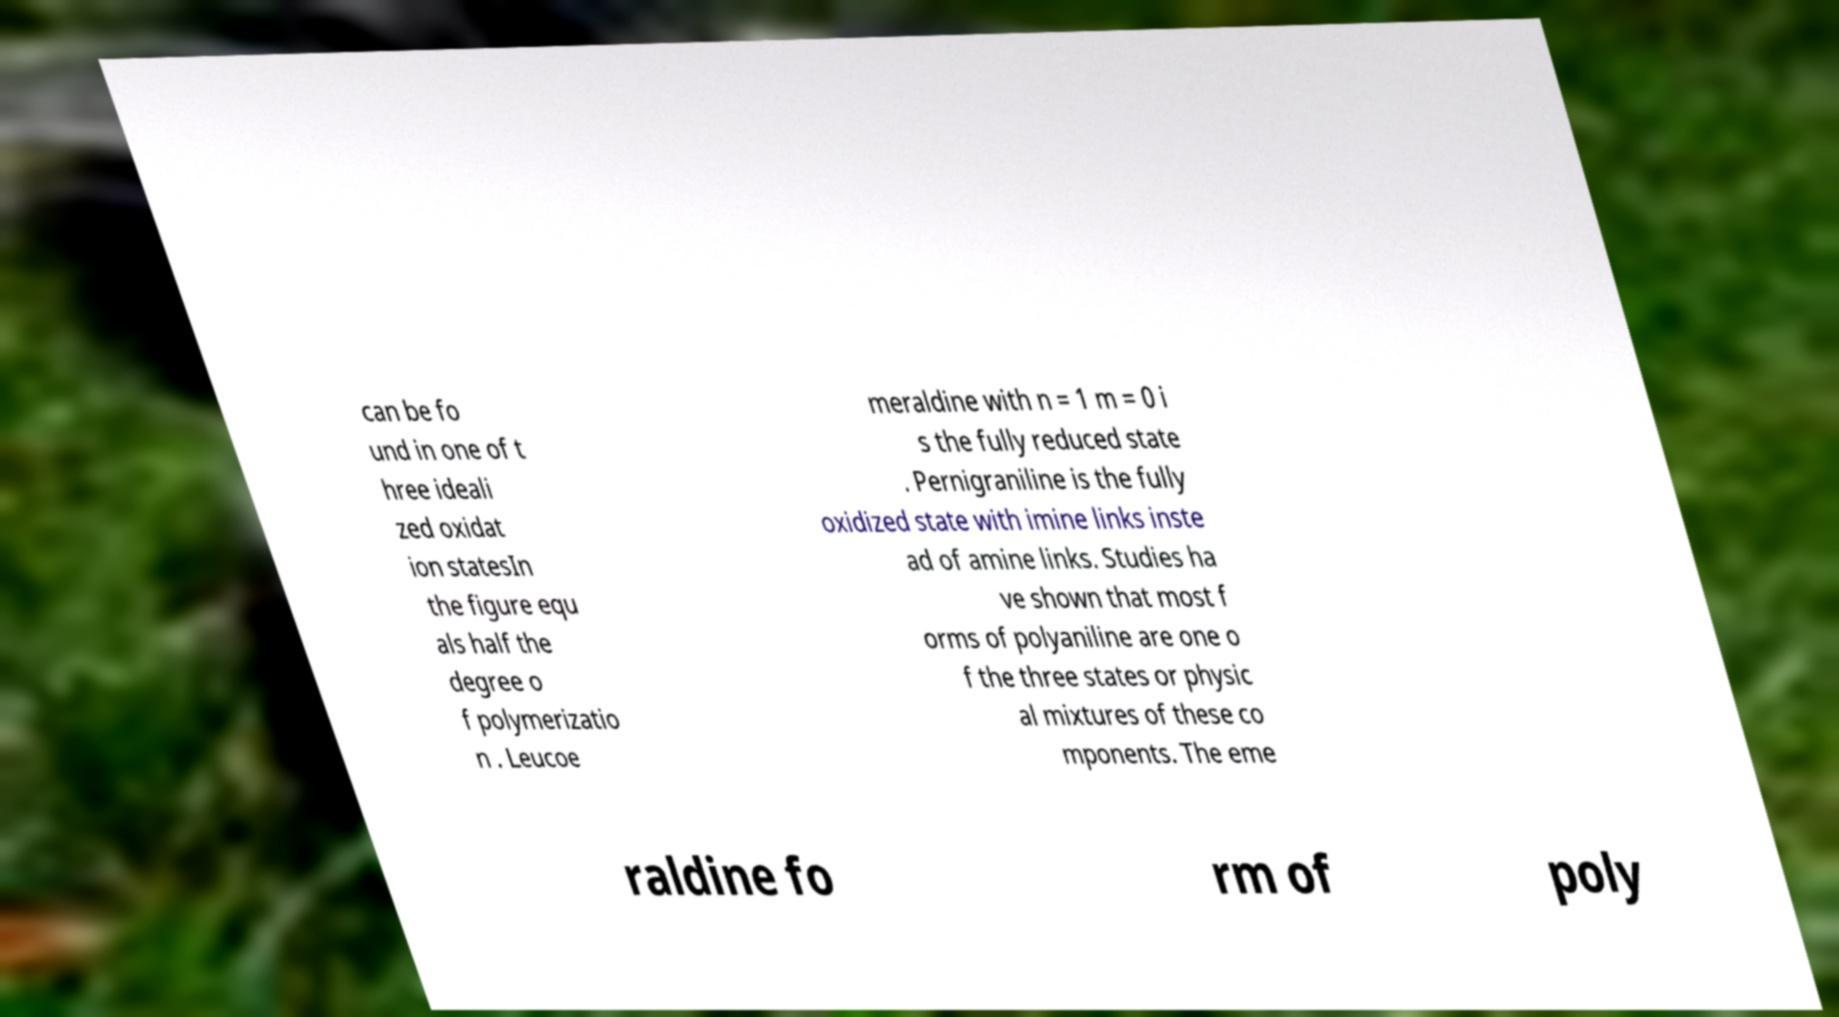Could you extract and type out the text from this image? can be fo und in one of t hree ideali zed oxidat ion statesIn the figure equ als half the degree o f polymerizatio n . Leucoe meraldine with n = 1 m = 0 i s the fully reduced state . Pernigraniline is the fully oxidized state with imine links inste ad of amine links. Studies ha ve shown that most f orms of polyaniline are one o f the three states or physic al mixtures of these co mponents. The eme raldine fo rm of poly 